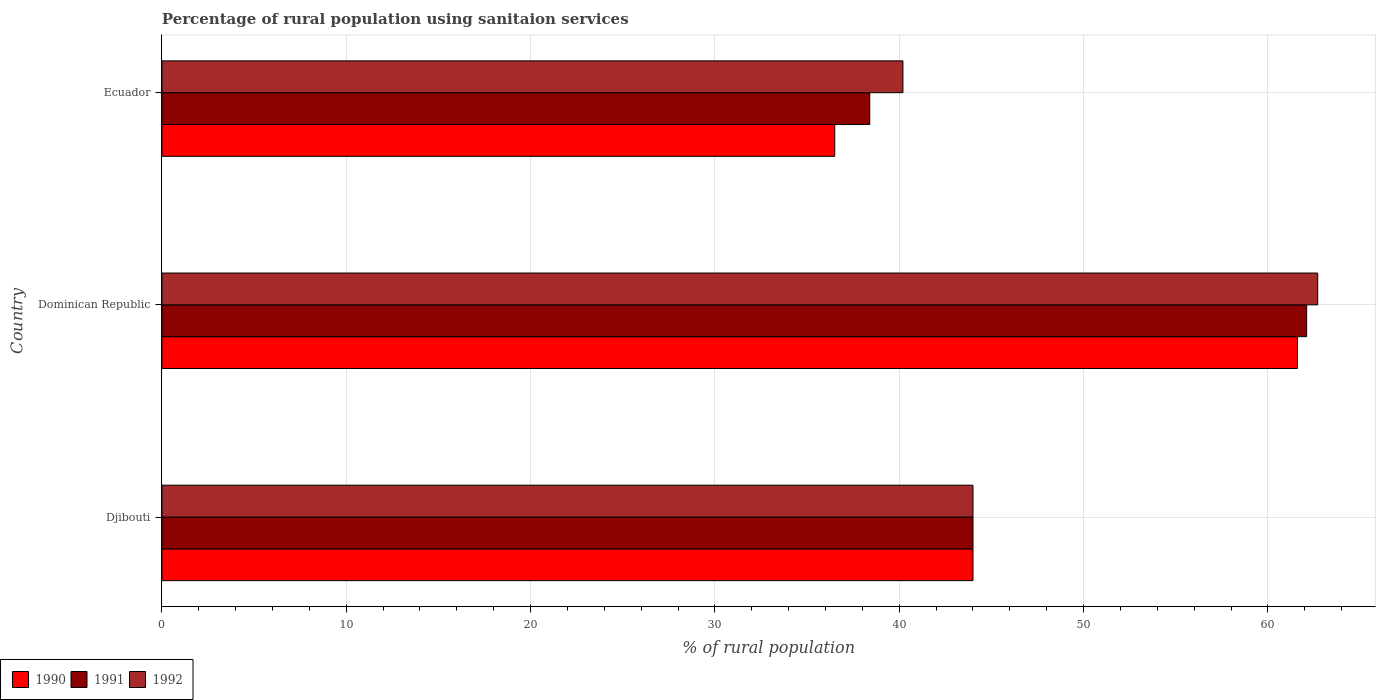How many different coloured bars are there?
Your response must be concise. 3. How many groups of bars are there?
Ensure brevity in your answer.  3. How many bars are there on the 1st tick from the bottom?
Offer a terse response. 3. What is the label of the 3rd group of bars from the top?
Keep it short and to the point. Djibouti. What is the percentage of rural population using sanitaion services in 1992 in Djibouti?
Provide a short and direct response. 44. Across all countries, what is the maximum percentage of rural population using sanitaion services in 1992?
Your answer should be very brief. 62.7. Across all countries, what is the minimum percentage of rural population using sanitaion services in 1992?
Give a very brief answer. 40.2. In which country was the percentage of rural population using sanitaion services in 1990 maximum?
Your answer should be very brief. Dominican Republic. In which country was the percentage of rural population using sanitaion services in 1991 minimum?
Your answer should be very brief. Ecuador. What is the total percentage of rural population using sanitaion services in 1992 in the graph?
Provide a succinct answer. 146.9. What is the difference between the percentage of rural population using sanitaion services in 1992 in Djibouti and that in Dominican Republic?
Offer a terse response. -18.7. What is the difference between the percentage of rural population using sanitaion services in 1992 in Djibouti and the percentage of rural population using sanitaion services in 1991 in Ecuador?
Provide a succinct answer. 5.6. What is the average percentage of rural population using sanitaion services in 1992 per country?
Give a very brief answer. 48.97. What is the difference between the percentage of rural population using sanitaion services in 1992 and percentage of rural population using sanitaion services in 1991 in Dominican Republic?
Offer a very short reply. 0.6. What is the ratio of the percentage of rural population using sanitaion services in 1991 in Dominican Republic to that in Ecuador?
Ensure brevity in your answer.  1.62. What is the difference between the highest and the second highest percentage of rural population using sanitaion services in 1990?
Keep it short and to the point. 17.6. Is the sum of the percentage of rural population using sanitaion services in 1992 in Djibouti and Ecuador greater than the maximum percentage of rural population using sanitaion services in 1991 across all countries?
Ensure brevity in your answer.  Yes. What does the 1st bar from the top in Ecuador represents?
Your answer should be very brief. 1992. What does the 2nd bar from the bottom in Djibouti represents?
Your answer should be very brief. 1991. How many bars are there?
Provide a succinct answer. 9. What is the difference between two consecutive major ticks on the X-axis?
Offer a terse response. 10. Does the graph contain grids?
Provide a succinct answer. Yes. What is the title of the graph?
Provide a short and direct response. Percentage of rural population using sanitaion services. Does "1992" appear as one of the legend labels in the graph?
Provide a succinct answer. Yes. What is the label or title of the X-axis?
Make the answer very short. % of rural population. What is the label or title of the Y-axis?
Offer a terse response. Country. What is the % of rural population of 1990 in Djibouti?
Your response must be concise. 44. What is the % of rural population in 1991 in Djibouti?
Keep it short and to the point. 44. What is the % of rural population in 1992 in Djibouti?
Ensure brevity in your answer.  44. What is the % of rural population of 1990 in Dominican Republic?
Your response must be concise. 61.6. What is the % of rural population in 1991 in Dominican Republic?
Offer a terse response. 62.1. What is the % of rural population in 1992 in Dominican Republic?
Provide a succinct answer. 62.7. What is the % of rural population of 1990 in Ecuador?
Offer a very short reply. 36.5. What is the % of rural population of 1991 in Ecuador?
Your answer should be very brief. 38.4. What is the % of rural population in 1992 in Ecuador?
Make the answer very short. 40.2. Across all countries, what is the maximum % of rural population of 1990?
Your answer should be compact. 61.6. Across all countries, what is the maximum % of rural population in 1991?
Your response must be concise. 62.1. Across all countries, what is the maximum % of rural population in 1992?
Give a very brief answer. 62.7. Across all countries, what is the minimum % of rural population of 1990?
Your answer should be very brief. 36.5. Across all countries, what is the minimum % of rural population of 1991?
Provide a short and direct response. 38.4. Across all countries, what is the minimum % of rural population of 1992?
Your answer should be compact. 40.2. What is the total % of rural population in 1990 in the graph?
Make the answer very short. 142.1. What is the total % of rural population of 1991 in the graph?
Your response must be concise. 144.5. What is the total % of rural population in 1992 in the graph?
Offer a very short reply. 146.9. What is the difference between the % of rural population in 1990 in Djibouti and that in Dominican Republic?
Make the answer very short. -17.6. What is the difference between the % of rural population of 1991 in Djibouti and that in Dominican Republic?
Make the answer very short. -18.1. What is the difference between the % of rural population of 1992 in Djibouti and that in Dominican Republic?
Give a very brief answer. -18.7. What is the difference between the % of rural population of 1991 in Djibouti and that in Ecuador?
Give a very brief answer. 5.6. What is the difference between the % of rural population of 1990 in Dominican Republic and that in Ecuador?
Ensure brevity in your answer.  25.1. What is the difference between the % of rural population in 1991 in Dominican Republic and that in Ecuador?
Your answer should be very brief. 23.7. What is the difference between the % of rural population in 1990 in Djibouti and the % of rural population in 1991 in Dominican Republic?
Provide a succinct answer. -18.1. What is the difference between the % of rural population in 1990 in Djibouti and the % of rural population in 1992 in Dominican Republic?
Provide a succinct answer. -18.7. What is the difference between the % of rural population in 1991 in Djibouti and the % of rural population in 1992 in Dominican Republic?
Offer a terse response. -18.7. What is the difference between the % of rural population in 1990 in Djibouti and the % of rural population in 1992 in Ecuador?
Provide a succinct answer. 3.8. What is the difference between the % of rural population in 1990 in Dominican Republic and the % of rural population in 1991 in Ecuador?
Provide a short and direct response. 23.2. What is the difference between the % of rural population of 1990 in Dominican Republic and the % of rural population of 1992 in Ecuador?
Ensure brevity in your answer.  21.4. What is the difference between the % of rural population in 1991 in Dominican Republic and the % of rural population in 1992 in Ecuador?
Make the answer very short. 21.9. What is the average % of rural population in 1990 per country?
Your response must be concise. 47.37. What is the average % of rural population in 1991 per country?
Your response must be concise. 48.17. What is the average % of rural population in 1992 per country?
Provide a short and direct response. 48.97. What is the difference between the % of rural population in 1991 and % of rural population in 1992 in Djibouti?
Provide a short and direct response. 0. What is the difference between the % of rural population of 1990 and % of rural population of 1992 in Dominican Republic?
Provide a succinct answer. -1.1. What is the difference between the % of rural population in 1991 and % of rural population in 1992 in Dominican Republic?
Ensure brevity in your answer.  -0.6. What is the ratio of the % of rural population in 1991 in Djibouti to that in Dominican Republic?
Ensure brevity in your answer.  0.71. What is the ratio of the % of rural population of 1992 in Djibouti to that in Dominican Republic?
Provide a short and direct response. 0.7. What is the ratio of the % of rural population in 1990 in Djibouti to that in Ecuador?
Offer a very short reply. 1.21. What is the ratio of the % of rural population of 1991 in Djibouti to that in Ecuador?
Offer a very short reply. 1.15. What is the ratio of the % of rural population of 1992 in Djibouti to that in Ecuador?
Provide a succinct answer. 1.09. What is the ratio of the % of rural population in 1990 in Dominican Republic to that in Ecuador?
Offer a very short reply. 1.69. What is the ratio of the % of rural population of 1991 in Dominican Republic to that in Ecuador?
Keep it short and to the point. 1.62. What is the ratio of the % of rural population of 1992 in Dominican Republic to that in Ecuador?
Give a very brief answer. 1.56. What is the difference between the highest and the second highest % of rural population in 1990?
Ensure brevity in your answer.  17.6. What is the difference between the highest and the second highest % of rural population of 1992?
Make the answer very short. 18.7. What is the difference between the highest and the lowest % of rural population in 1990?
Provide a short and direct response. 25.1. What is the difference between the highest and the lowest % of rural population of 1991?
Offer a terse response. 23.7. 